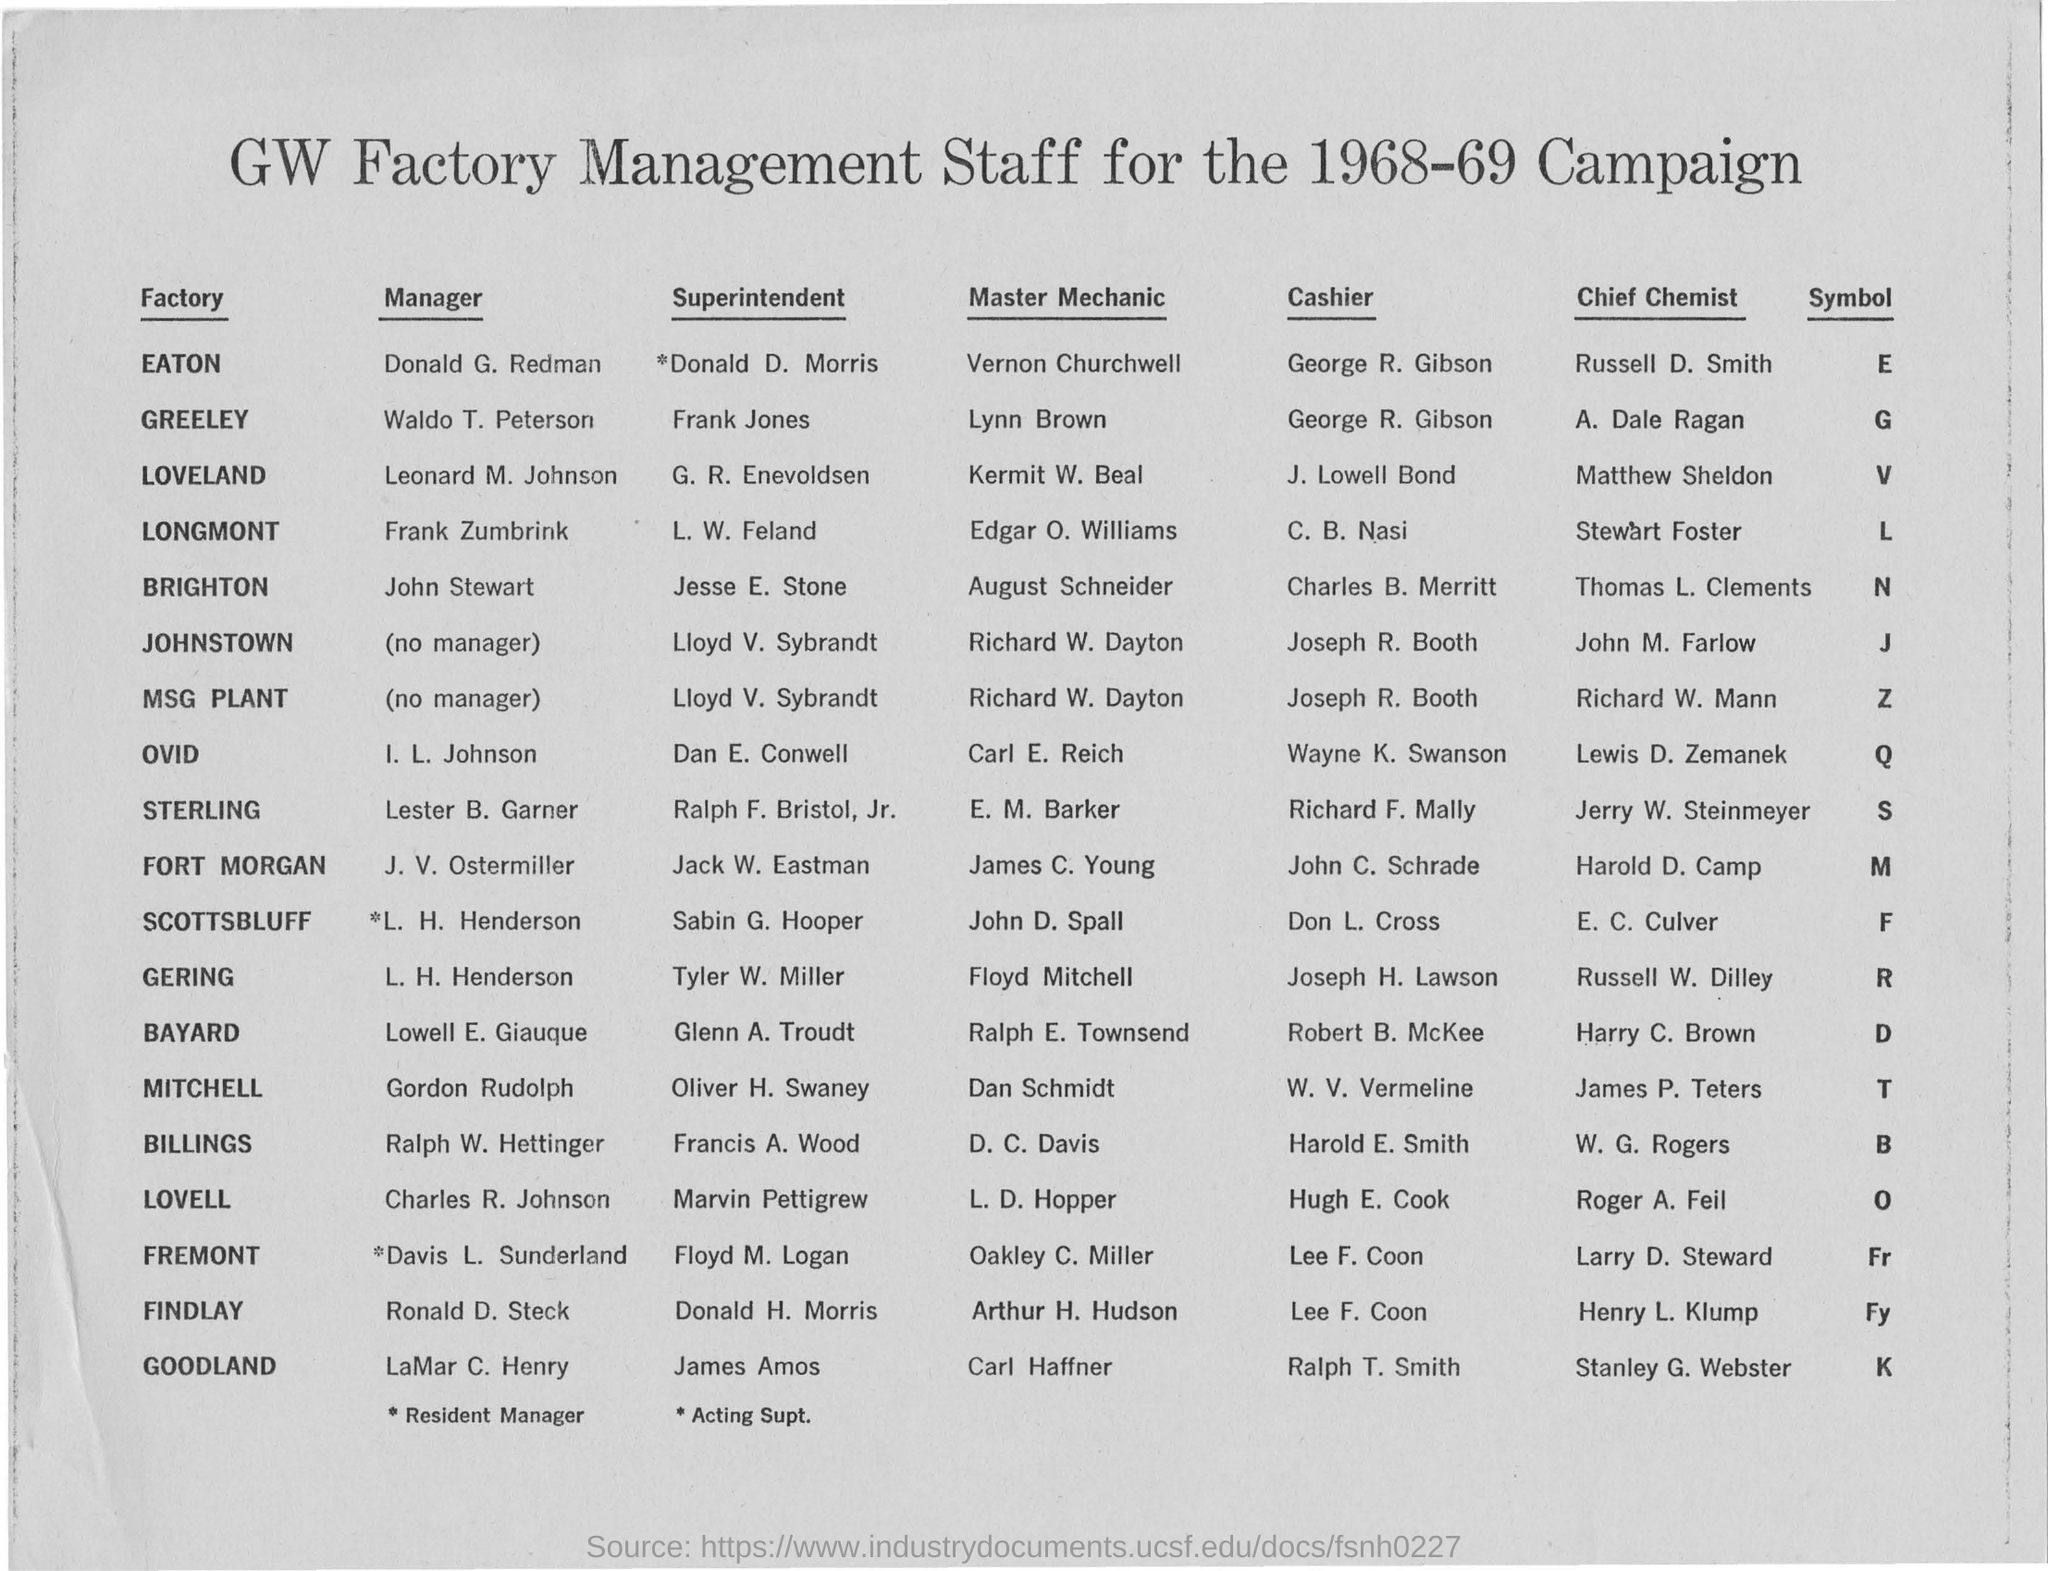When is the campaign held?
Provide a succinct answer. 1968-69. What is the symbol for MSG Plant?
Offer a very short reply. Z. Who is the manager for the Eaton factory?
Provide a short and direct response. DONALD G. REDMAN. Who is the cashier for Findlay factory?
Your answer should be compact. Lee F. Coon. 